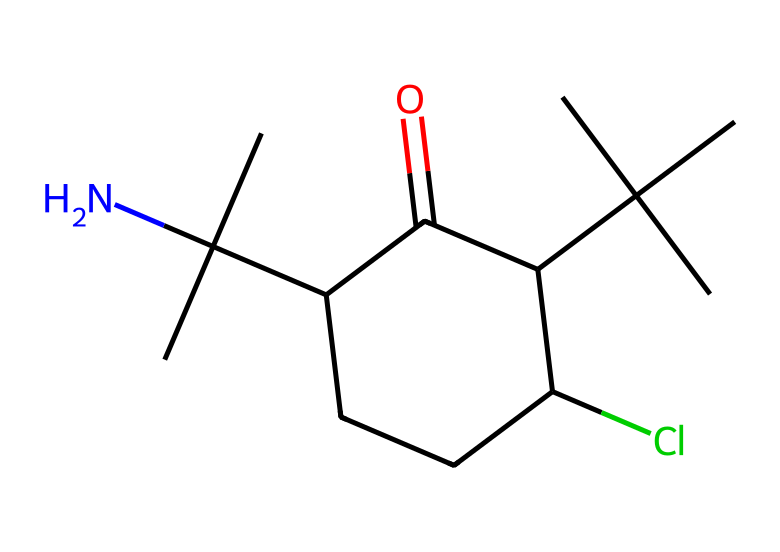What is the molecular formula of bupropion based on the SMILES? The SMILES representation contains the following atoms: there are 12 carbon (C) atoms, 16 hydrogen (H) atoms, 1 nitrogen (N) atom, and 1 oxygen (O) atom. Combining these gives the molecular formula as C12H16ClN.
Answer: C12H16ClN How many carbon atoms are present in the structure? By counting the carbon symbols (C) in the SMILES representation, there are 12 distinct carbon atoms present.
Answer: 12 What functional group is indicated by the presence of 'C(=O)' in the structure? The 'C(=O)' notation shows that there is a carbon atom bonded to an oxygen atom with a double bond, indicating a carbonyl functional group. A carbonyl can be part of different functional groups, and in this case, it suggests the presence of a ketone as part of the overall structure.
Answer: carbonyl Does this molecule contain any halogens? The presence of the 'Cl' symbol in the SMILES indicates that there is a chlorine atom attached to the carbon chain, confirming that the molecule does contain a halogen.
Answer: Yes What indicates that this structure is organometallic? While there are no explicit metal atoms in the SMILES representation, organometallic compounds typically involve carbon-metal bonds. If this molecule were to contain a transition metal or another type of metal directly bonded to the carbon atoms, it would classify as organometallic. Since it's primarily organic with no metal shown here, it does not classify as traditional organometallic.
Answer: No What is the degree of saturation in this molecule? The degree of saturation can be determined by considering the number of rings and multiple bonds present. For bupropion, noting the presence of rings and double bonds suggests that it is fully saturated, meaning an absence of any unnecessary hydrogen atoms beyond those accounted for in the structure.
Answer: Fully saturated Which component of the structure contributes to the antidepressant activity? The nitrogen atom in the structure (N) is significant as it is often associated with neurotransmitters and affects mood regulation, contributing to the antidepressant activity of bupropion.
Answer: Nitrogen 